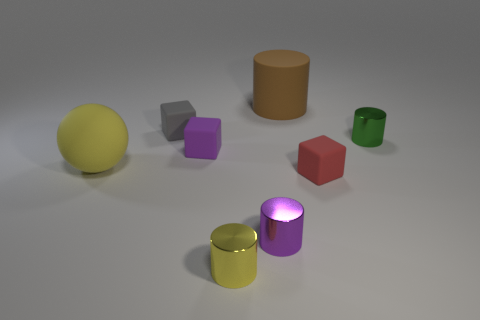Subtract all small purple blocks. How many blocks are left? 2 Subtract all red cubes. How many cubes are left? 2 Add 2 blocks. How many objects exist? 10 Subtract all cubes. How many objects are left? 5 Subtract 1 blocks. How many blocks are left? 2 Add 5 tiny yellow matte objects. How many tiny yellow matte objects exist? 5 Subtract 0 blue balls. How many objects are left? 8 Subtract all purple cylinders. Subtract all blue spheres. How many cylinders are left? 3 Subtract all purple cubes. How many purple cylinders are left? 1 Subtract all large yellow things. Subtract all yellow matte things. How many objects are left? 6 